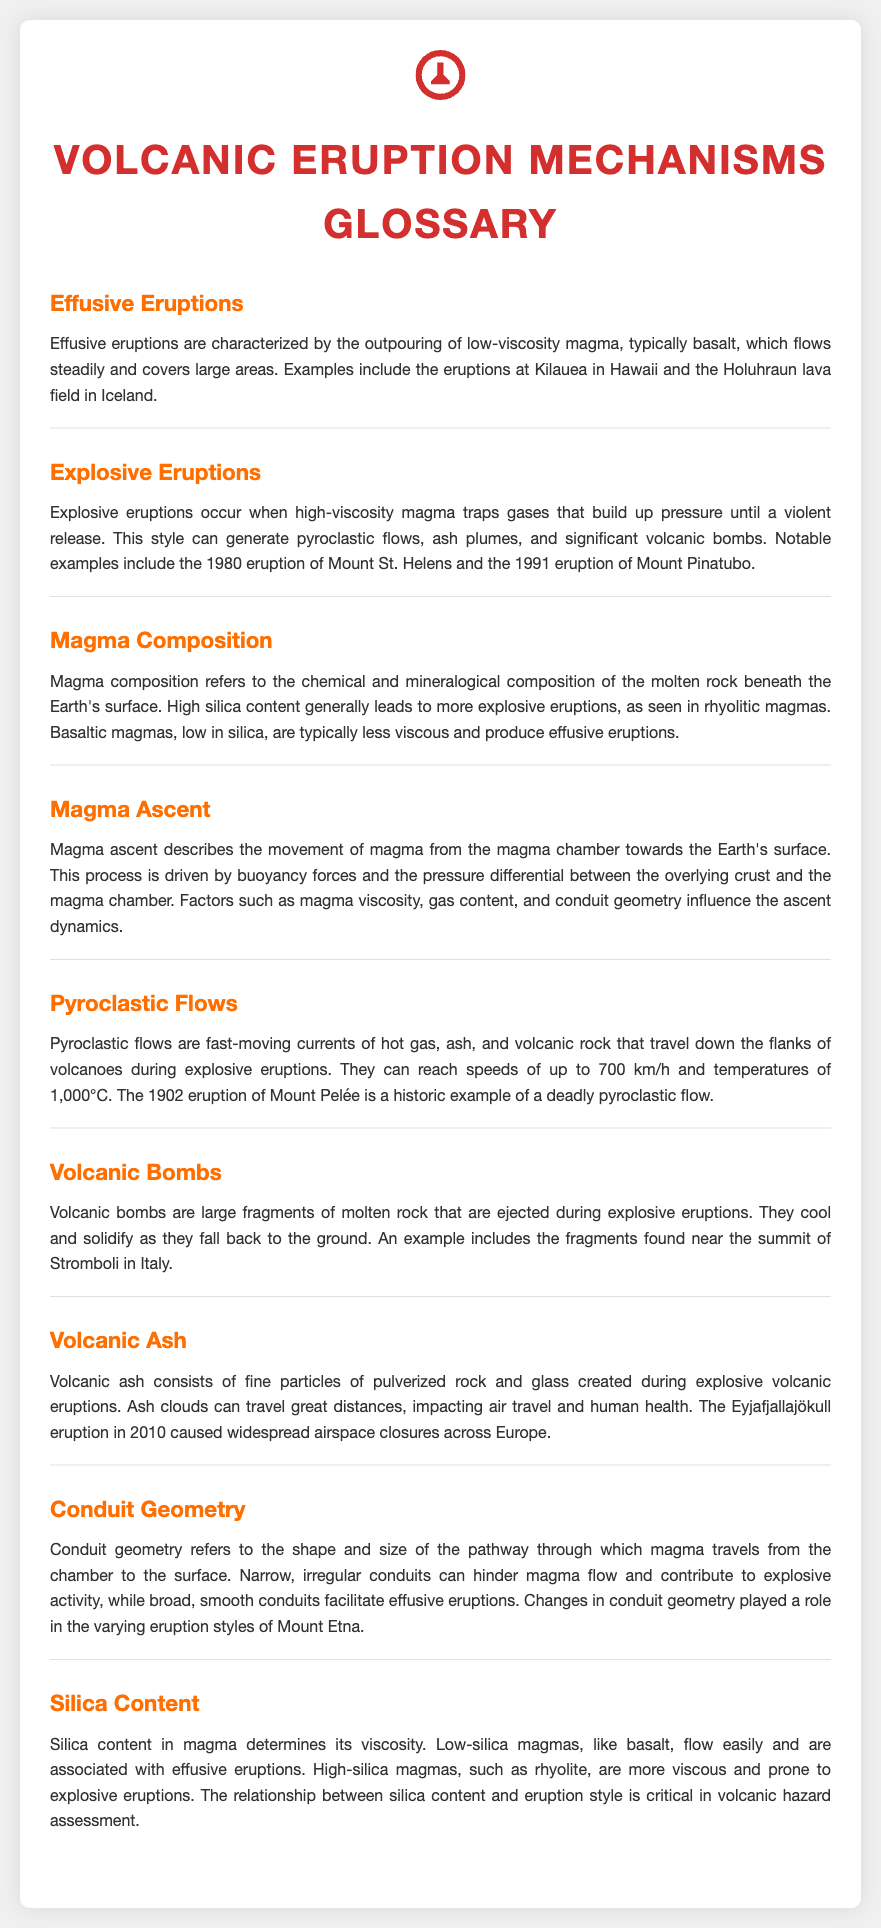What are effusive eruptions characterized by? Effusive eruptions are characterized by the outpouring of low-viscosity magma, typically basalt, which flows steadily and covers large areas.
Answer: Outpouring of low-viscosity magma What is a notable example of explosive eruption? The document provides notable examples of explosive eruptions, specifically mentioning the 1980 eruption of Mount St. Helens.
Answer: 1980 eruption of Mount St. Helens How does magma composition affect eruption style? The document states that high silica content generally leads to more explosive eruptions, influencing the eruption style based on the magma composition.
Answer: High silica content leads to explosive eruptions What is the speed of pyroclastic flows? According to the document, pyroclastic flows can reach speeds of up to 700 km/h.
Answer: 700 km/h What role does conduit geometry play in eruptions? Conduit geometry refers to the shape and size of the pathway through which magma travels, affecting magma flow and eruption styles.
Answer: Shape and size of the pathway What do volcanic bombs cool into? The document states that volcanic bombs cool and solidify as they fall back to the ground.
Answer: Cool and solidify How does silica content influence viscosity? The document explains that silica content in magma determines its viscosity, with low-silica magmas flowing easily and high-silica magmas being more viscous.
Answer: Determines viscosity What is the main factor driving magma ascent? The document mentions that magma ascent is driven by buoyancy forces and the pressure differential between the crust and the magma chamber.
Answer: Buoyancy forces and pressure differential 